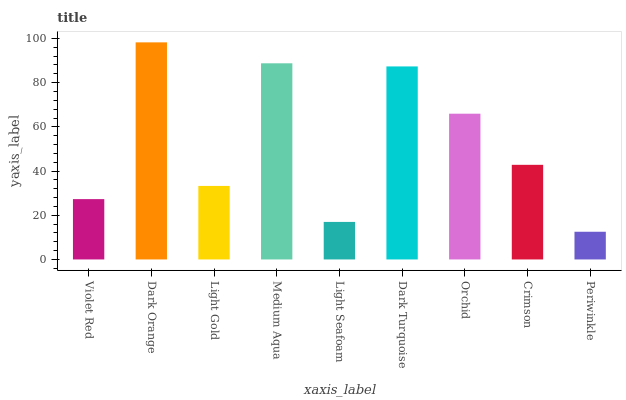Is Periwinkle the minimum?
Answer yes or no. Yes. Is Dark Orange the maximum?
Answer yes or no. Yes. Is Light Gold the minimum?
Answer yes or no. No. Is Light Gold the maximum?
Answer yes or no. No. Is Dark Orange greater than Light Gold?
Answer yes or no. Yes. Is Light Gold less than Dark Orange?
Answer yes or no. Yes. Is Light Gold greater than Dark Orange?
Answer yes or no. No. Is Dark Orange less than Light Gold?
Answer yes or no. No. Is Crimson the high median?
Answer yes or no. Yes. Is Crimson the low median?
Answer yes or no. Yes. Is Light Gold the high median?
Answer yes or no. No. Is Dark Orange the low median?
Answer yes or no. No. 